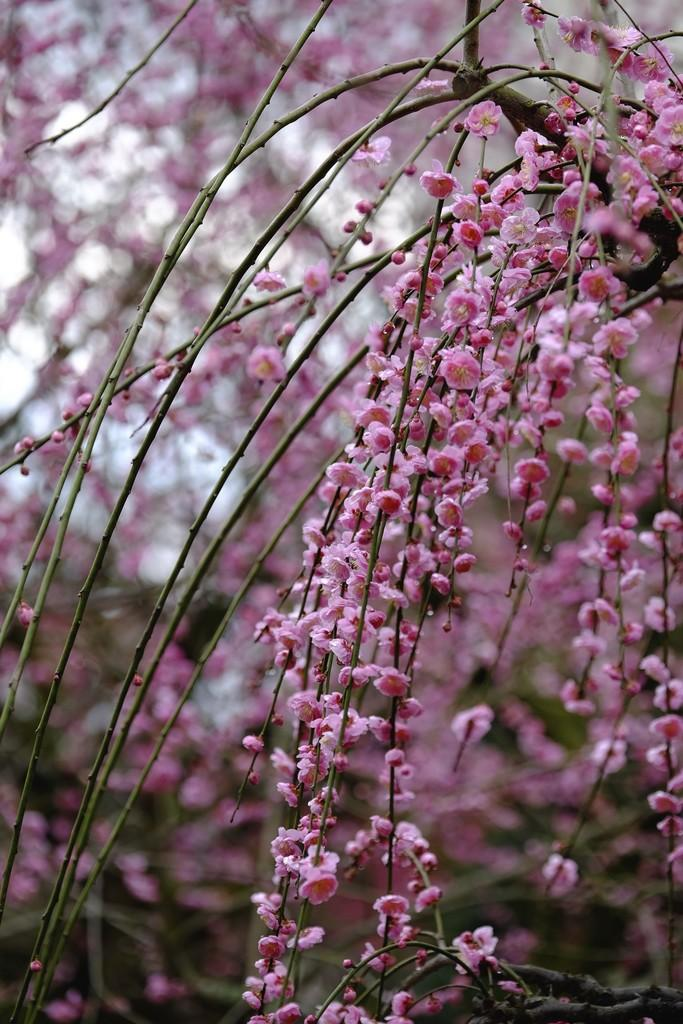What type of natural element is present in the image? There is a tree in the image. What class of animal is sitting on the foot of the tree in the image? There is no animal present in the image, and therefore no class of animal can be identified. 